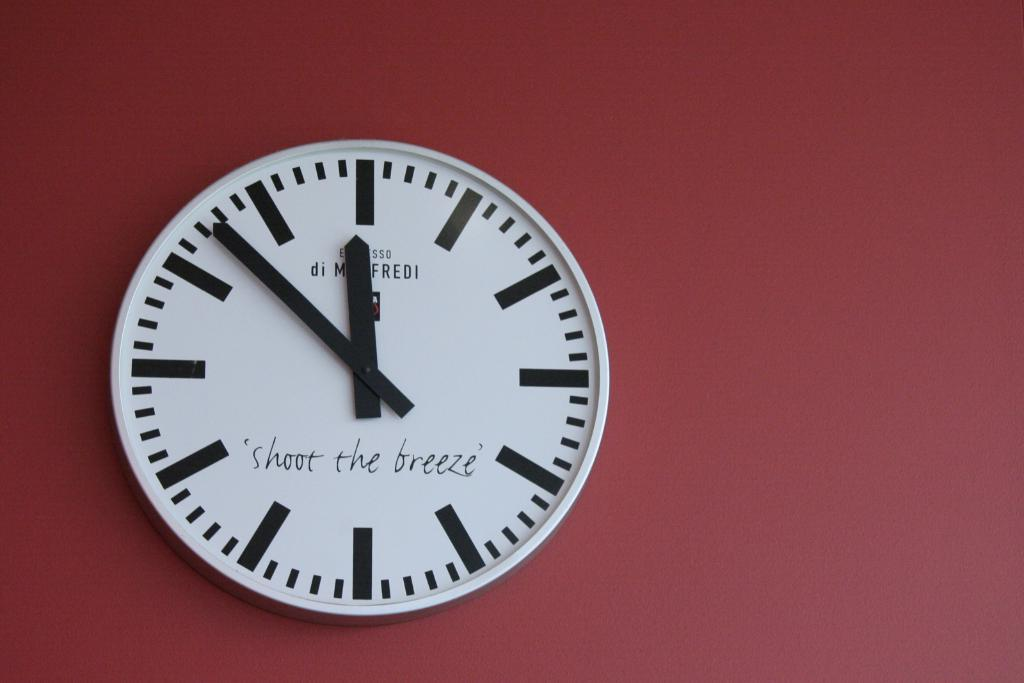<image>
Describe the image concisely. A wall clock says "shoot the breeze" on it. 